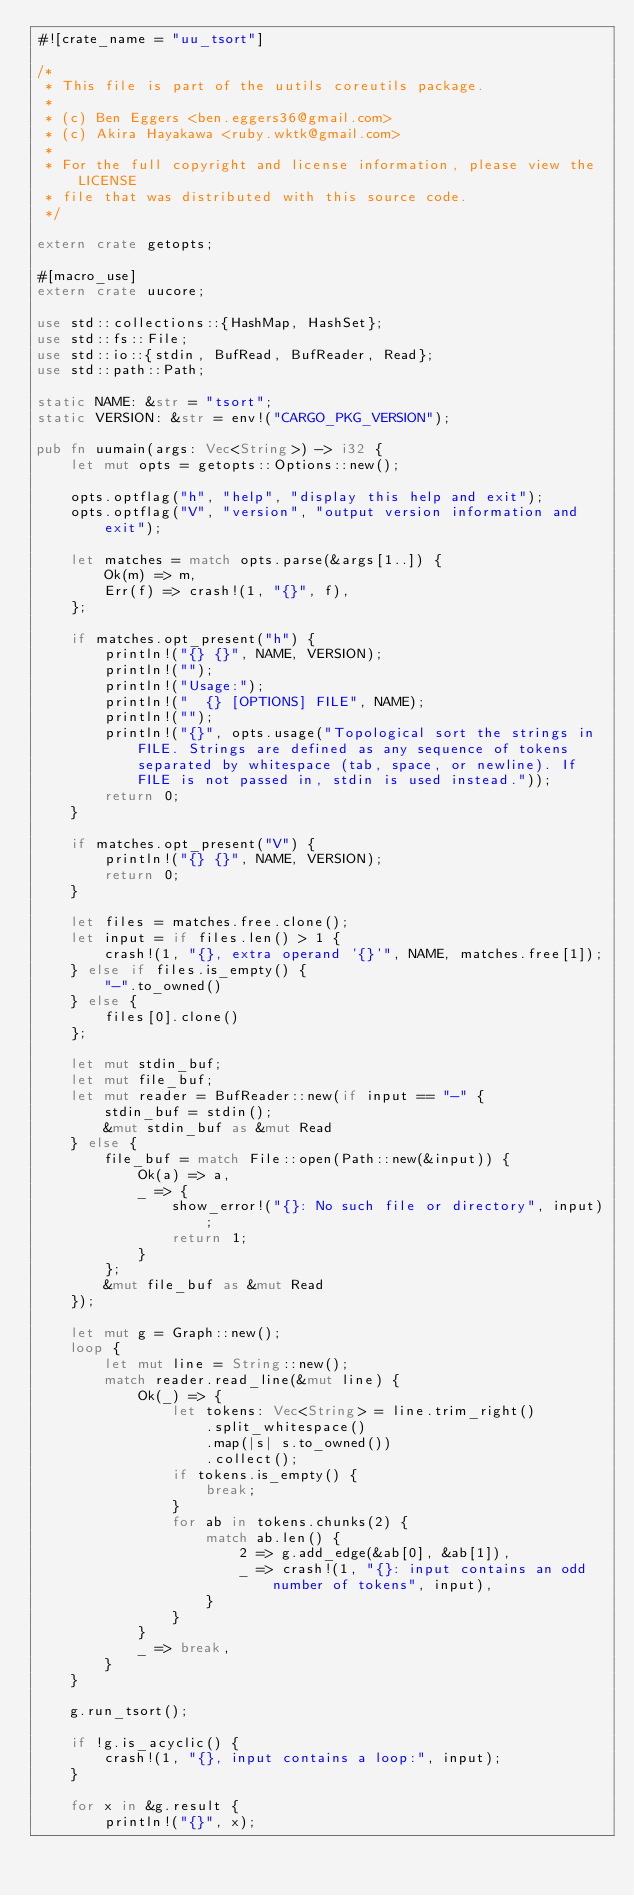<code> <loc_0><loc_0><loc_500><loc_500><_Rust_>#![crate_name = "uu_tsort"]

/*
 * This file is part of the uutils coreutils package.
 *
 * (c) Ben Eggers <ben.eggers36@gmail.com>
 * (c) Akira Hayakawa <ruby.wktk@gmail.com>
 *
 * For the full copyright and license information, please view the LICENSE
 * file that was distributed with this source code.
 */

extern crate getopts;

#[macro_use]
extern crate uucore;

use std::collections::{HashMap, HashSet};
use std::fs::File;
use std::io::{stdin, BufRead, BufReader, Read};
use std::path::Path;

static NAME: &str = "tsort";
static VERSION: &str = env!("CARGO_PKG_VERSION");

pub fn uumain(args: Vec<String>) -> i32 {
    let mut opts = getopts::Options::new();

    opts.optflag("h", "help", "display this help and exit");
    opts.optflag("V", "version", "output version information and exit");

    let matches = match opts.parse(&args[1..]) {
        Ok(m) => m,
        Err(f) => crash!(1, "{}", f),
    };

    if matches.opt_present("h") {
        println!("{} {}", NAME, VERSION);
        println!("");
        println!("Usage:");
        println!("  {} [OPTIONS] FILE", NAME);
        println!("");
        println!("{}", opts.usage("Topological sort the strings in FILE. Strings are defined as any sequence of tokens separated by whitespace (tab, space, or newline). If FILE is not passed in, stdin is used instead."));
        return 0;
    }

    if matches.opt_present("V") {
        println!("{} {}", NAME, VERSION);
        return 0;
    }

    let files = matches.free.clone();
    let input = if files.len() > 1 {
        crash!(1, "{}, extra operand '{}'", NAME, matches.free[1]);
    } else if files.is_empty() {
        "-".to_owned()
    } else {
        files[0].clone()
    };

    let mut stdin_buf;
    let mut file_buf;
    let mut reader = BufReader::new(if input == "-" {
        stdin_buf = stdin();
        &mut stdin_buf as &mut Read
    } else {
        file_buf = match File::open(Path::new(&input)) {
            Ok(a) => a,
            _ => {
                show_error!("{}: No such file or directory", input);
                return 1;
            }
        };
        &mut file_buf as &mut Read
    });

    let mut g = Graph::new();
    loop {
        let mut line = String::new();
        match reader.read_line(&mut line) {
            Ok(_) => {
                let tokens: Vec<String> = line.trim_right()
                    .split_whitespace()
                    .map(|s| s.to_owned())
                    .collect();
                if tokens.is_empty() {
                    break;
                }
                for ab in tokens.chunks(2) {
                    match ab.len() {
                        2 => g.add_edge(&ab[0], &ab[1]),
                        _ => crash!(1, "{}: input contains an odd number of tokens", input),
                    }
                }
            }
            _ => break,
        }
    }

    g.run_tsort();

    if !g.is_acyclic() {
        crash!(1, "{}, input contains a loop:", input);
    }

    for x in &g.result {
        println!("{}", x);</code> 